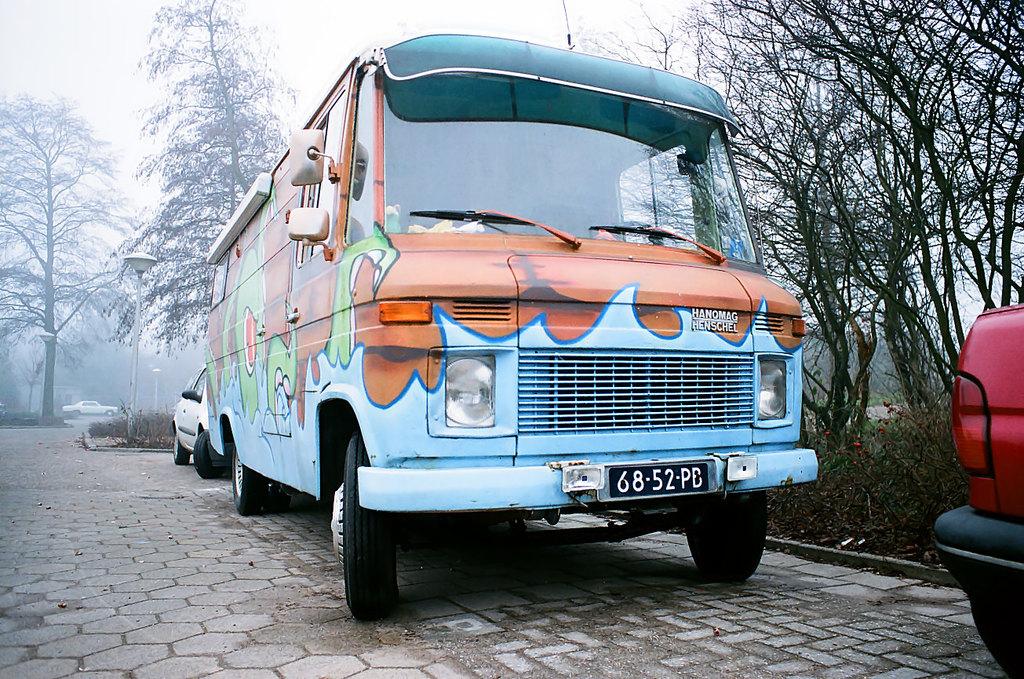What is the plate number of the bus?
Offer a terse response. 6852pb. 